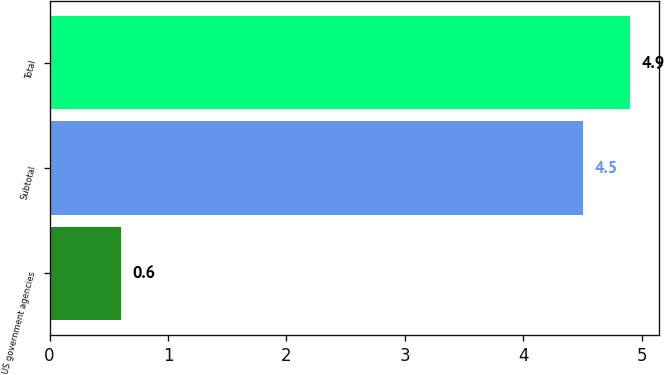Convert chart. <chart><loc_0><loc_0><loc_500><loc_500><bar_chart><fcel>US government agencies<fcel>Subtotal<fcel>Total<nl><fcel>0.6<fcel>4.5<fcel>4.9<nl></chart> 